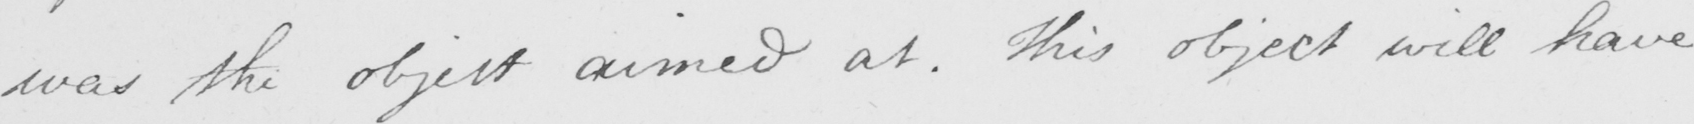Please provide the text content of this handwritten line. was the object aimed at . This object will have 